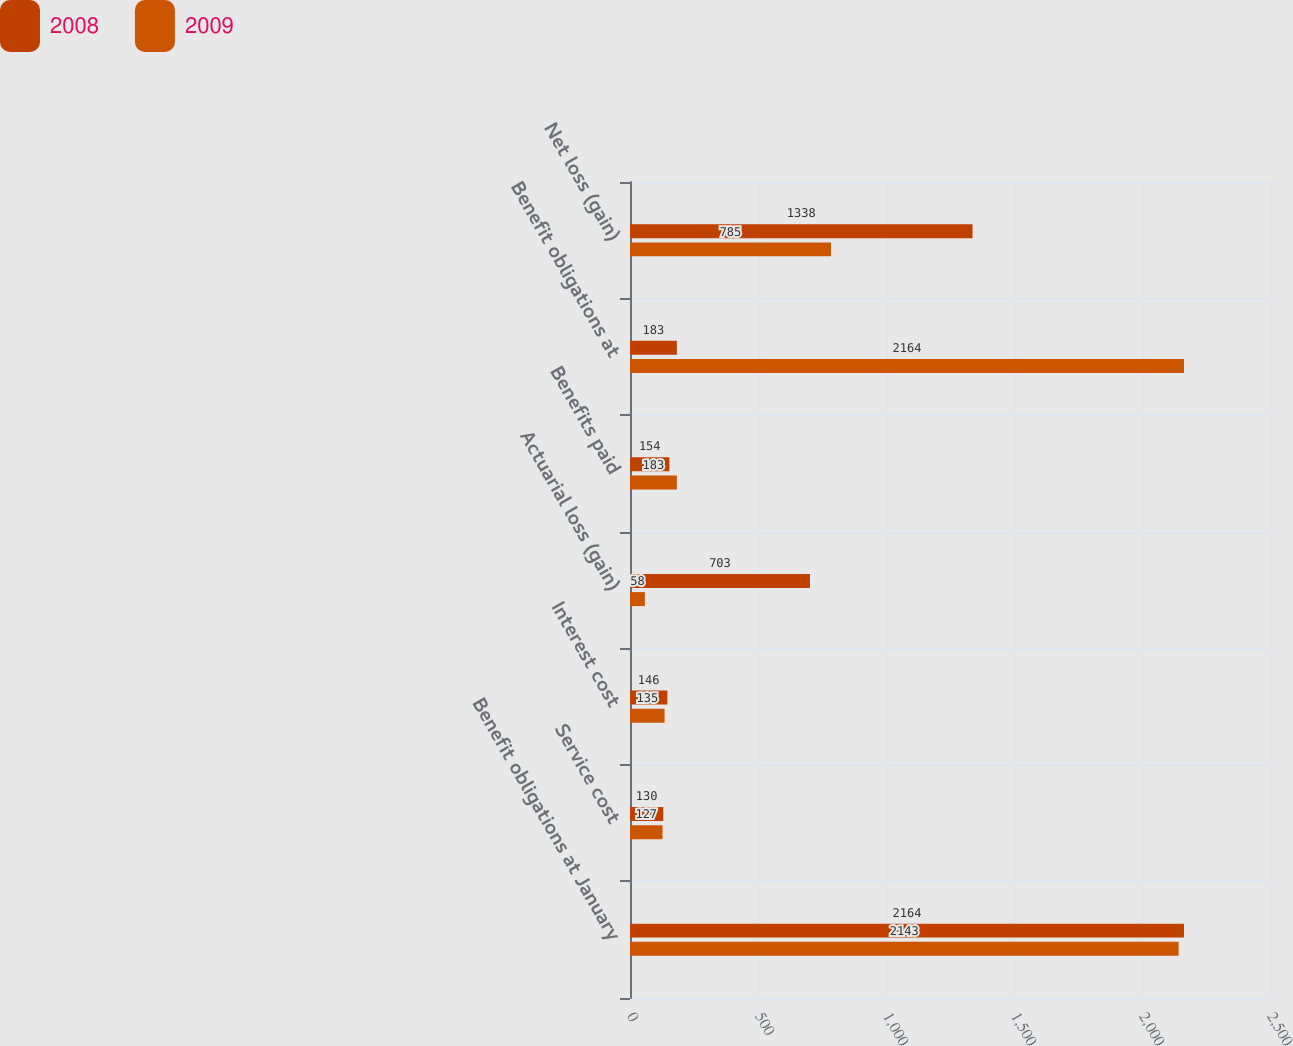Convert chart. <chart><loc_0><loc_0><loc_500><loc_500><stacked_bar_chart><ecel><fcel>Benefit obligations at January<fcel>Service cost<fcel>Interest cost<fcel>Actuarial loss (gain)<fcel>Benefits paid<fcel>Benefit obligations at<fcel>Net loss (gain)<nl><fcel>2008<fcel>2164<fcel>130<fcel>146<fcel>703<fcel>154<fcel>183<fcel>1338<nl><fcel>2009<fcel>2143<fcel>127<fcel>135<fcel>58<fcel>183<fcel>2164<fcel>785<nl></chart> 